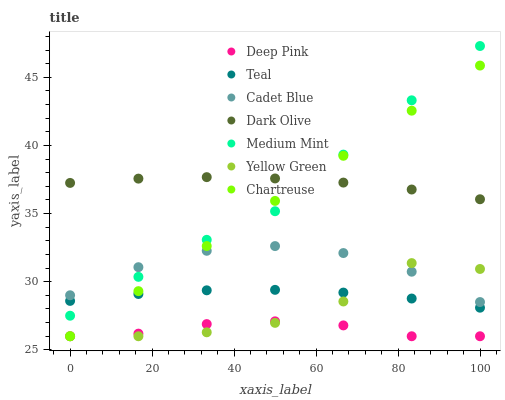Does Deep Pink have the minimum area under the curve?
Answer yes or no. Yes. Does Dark Olive have the maximum area under the curve?
Answer yes or no. Yes. Does Cadet Blue have the minimum area under the curve?
Answer yes or no. No. Does Cadet Blue have the maximum area under the curve?
Answer yes or no. No. Is Chartreuse the smoothest?
Answer yes or no. Yes. Is Yellow Green the roughest?
Answer yes or no. Yes. Is Cadet Blue the smoothest?
Answer yes or no. No. Is Cadet Blue the roughest?
Answer yes or no. No. Does Yellow Green have the lowest value?
Answer yes or no. Yes. Does Cadet Blue have the lowest value?
Answer yes or no. No. Does Medium Mint have the highest value?
Answer yes or no. Yes. Does Cadet Blue have the highest value?
Answer yes or no. No. Is Deep Pink less than Dark Olive?
Answer yes or no. Yes. Is Medium Mint greater than Deep Pink?
Answer yes or no. Yes. Does Teal intersect Yellow Green?
Answer yes or no. Yes. Is Teal less than Yellow Green?
Answer yes or no. No. Is Teal greater than Yellow Green?
Answer yes or no. No. Does Deep Pink intersect Dark Olive?
Answer yes or no. No. 